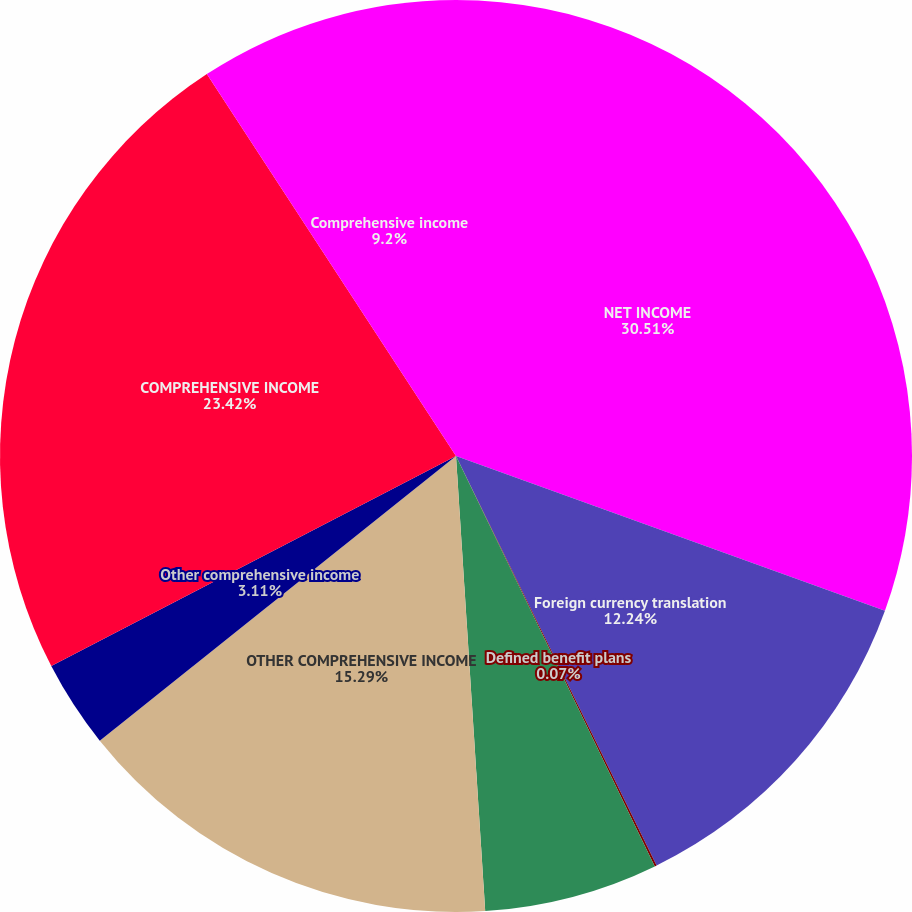Convert chart to OTSL. <chart><loc_0><loc_0><loc_500><loc_500><pie_chart><fcel>NET INCOME<fcel>Foreign currency translation<fcel>Defined benefit plans<fcel>Cash flow hedges<fcel>OTHER COMPREHENSIVE INCOME<fcel>Other comprehensive income<fcel>COMPREHENSIVE INCOME<fcel>Comprehensive income<nl><fcel>30.51%<fcel>12.24%<fcel>0.07%<fcel>6.16%<fcel>15.29%<fcel>3.11%<fcel>23.42%<fcel>9.2%<nl></chart> 